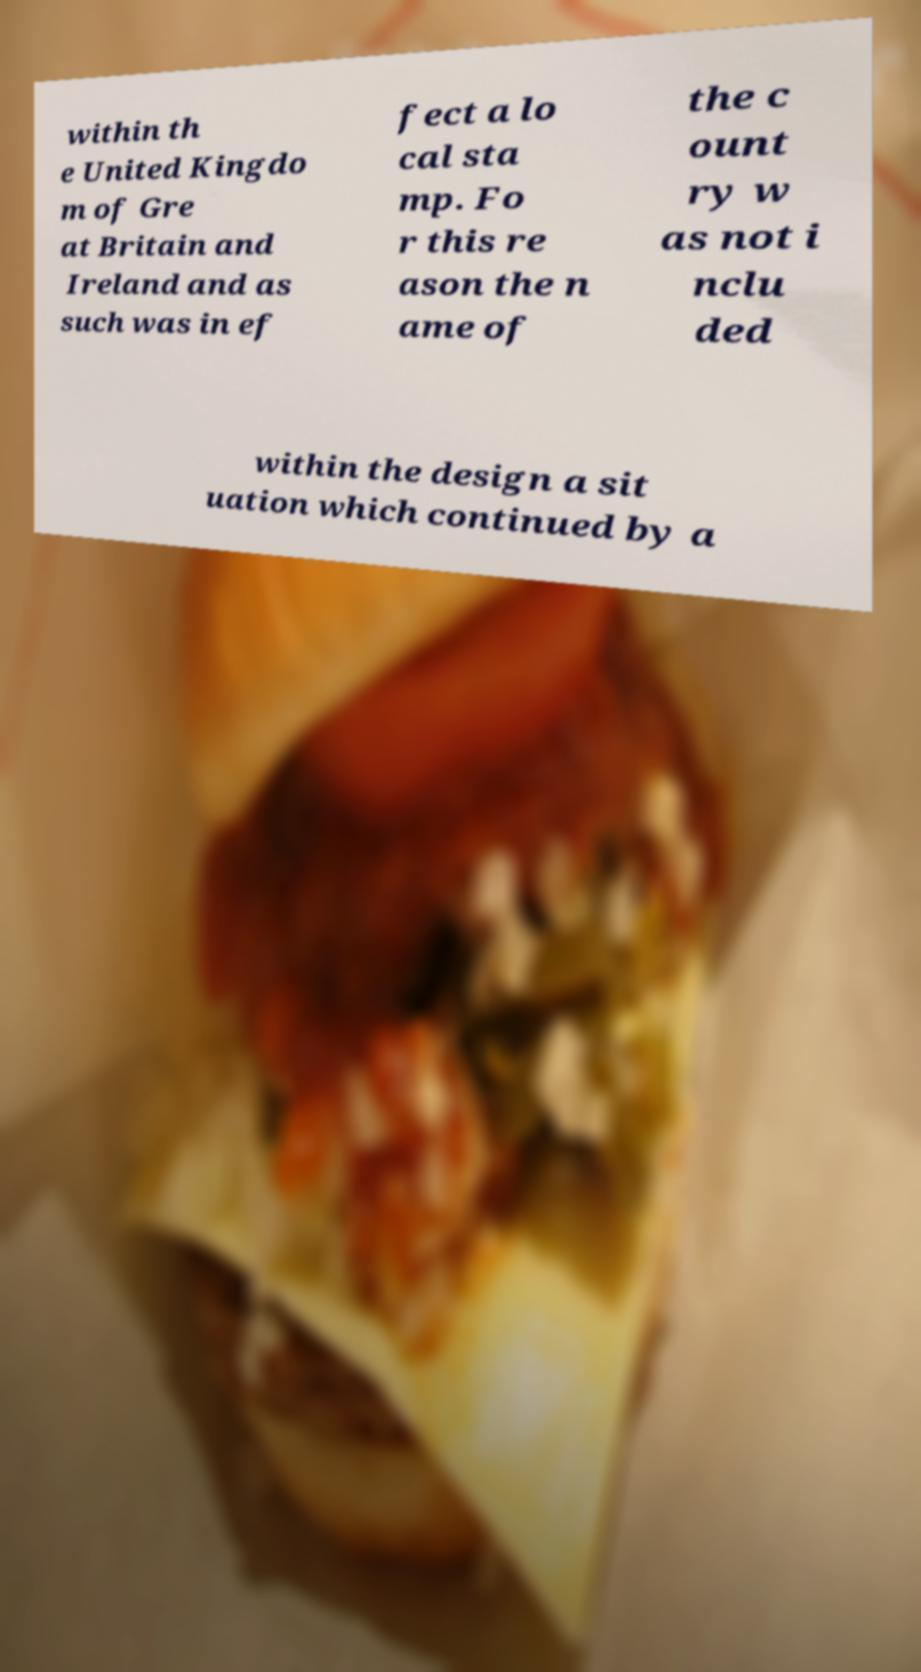Could you assist in decoding the text presented in this image and type it out clearly? within th e United Kingdo m of Gre at Britain and Ireland and as such was in ef fect a lo cal sta mp. Fo r this re ason the n ame of the c ount ry w as not i nclu ded within the design a sit uation which continued by a 